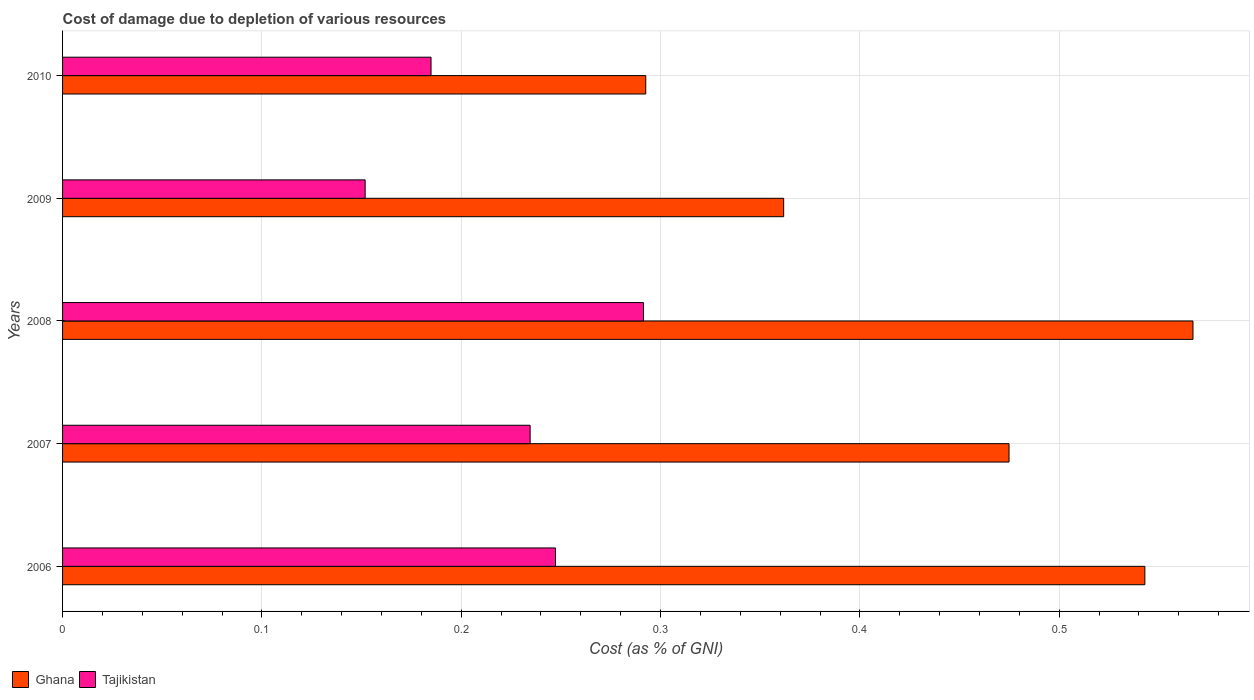Are the number of bars per tick equal to the number of legend labels?
Make the answer very short. Yes. How many bars are there on the 4th tick from the top?
Keep it short and to the point. 2. How many bars are there on the 3rd tick from the bottom?
Your answer should be compact. 2. What is the label of the 1st group of bars from the top?
Offer a terse response. 2010. What is the cost of damage caused due to the depletion of various resources in Ghana in 2010?
Provide a succinct answer. 0.29. Across all years, what is the maximum cost of damage caused due to the depletion of various resources in Ghana?
Your response must be concise. 0.57. Across all years, what is the minimum cost of damage caused due to the depletion of various resources in Tajikistan?
Offer a terse response. 0.15. In which year was the cost of damage caused due to the depletion of various resources in Tajikistan maximum?
Provide a succinct answer. 2008. What is the total cost of damage caused due to the depletion of various resources in Ghana in the graph?
Provide a short and direct response. 2.24. What is the difference between the cost of damage caused due to the depletion of various resources in Ghana in 2009 and that in 2010?
Offer a very short reply. 0.07. What is the difference between the cost of damage caused due to the depletion of various resources in Tajikistan in 2009 and the cost of damage caused due to the depletion of various resources in Ghana in 2007?
Your answer should be compact. -0.32. What is the average cost of damage caused due to the depletion of various resources in Tajikistan per year?
Your answer should be very brief. 0.22. In the year 2009, what is the difference between the cost of damage caused due to the depletion of various resources in Tajikistan and cost of damage caused due to the depletion of various resources in Ghana?
Your answer should be very brief. -0.21. What is the ratio of the cost of damage caused due to the depletion of various resources in Ghana in 2006 to that in 2008?
Give a very brief answer. 0.96. What is the difference between the highest and the second highest cost of damage caused due to the depletion of various resources in Tajikistan?
Make the answer very short. 0.04. What is the difference between the highest and the lowest cost of damage caused due to the depletion of various resources in Ghana?
Your answer should be very brief. 0.27. Is the sum of the cost of damage caused due to the depletion of various resources in Ghana in 2006 and 2010 greater than the maximum cost of damage caused due to the depletion of various resources in Tajikistan across all years?
Keep it short and to the point. Yes. What does the 1st bar from the top in 2009 represents?
Your answer should be very brief. Tajikistan. What does the 1st bar from the bottom in 2010 represents?
Provide a short and direct response. Ghana. How many bars are there?
Offer a very short reply. 10. What is the difference between two consecutive major ticks on the X-axis?
Your response must be concise. 0.1. Are the values on the major ticks of X-axis written in scientific E-notation?
Give a very brief answer. No. Does the graph contain any zero values?
Your answer should be compact. No. How many legend labels are there?
Keep it short and to the point. 2. What is the title of the graph?
Give a very brief answer. Cost of damage due to depletion of various resources. What is the label or title of the X-axis?
Offer a very short reply. Cost (as % of GNI). What is the Cost (as % of GNI) of Ghana in 2006?
Your answer should be compact. 0.54. What is the Cost (as % of GNI) of Tajikistan in 2006?
Make the answer very short. 0.25. What is the Cost (as % of GNI) of Ghana in 2007?
Make the answer very short. 0.47. What is the Cost (as % of GNI) in Tajikistan in 2007?
Your answer should be very brief. 0.23. What is the Cost (as % of GNI) of Ghana in 2008?
Give a very brief answer. 0.57. What is the Cost (as % of GNI) of Tajikistan in 2008?
Your answer should be compact. 0.29. What is the Cost (as % of GNI) of Ghana in 2009?
Provide a succinct answer. 0.36. What is the Cost (as % of GNI) of Tajikistan in 2009?
Your answer should be very brief. 0.15. What is the Cost (as % of GNI) of Ghana in 2010?
Your answer should be compact. 0.29. What is the Cost (as % of GNI) in Tajikistan in 2010?
Ensure brevity in your answer.  0.18. Across all years, what is the maximum Cost (as % of GNI) of Ghana?
Your response must be concise. 0.57. Across all years, what is the maximum Cost (as % of GNI) in Tajikistan?
Your response must be concise. 0.29. Across all years, what is the minimum Cost (as % of GNI) in Ghana?
Your answer should be compact. 0.29. Across all years, what is the minimum Cost (as % of GNI) of Tajikistan?
Keep it short and to the point. 0.15. What is the total Cost (as % of GNI) of Ghana in the graph?
Keep it short and to the point. 2.24. What is the total Cost (as % of GNI) of Tajikistan in the graph?
Make the answer very short. 1.11. What is the difference between the Cost (as % of GNI) in Ghana in 2006 and that in 2007?
Your response must be concise. 0.07. What is the difference between the Cost (as % of GNI) of Tajikistan in 2006 and that in 2007?
Your answer should be very brief. 0.01. What is the difference between the Cost (as % of GNI) of Ghana in 2006 and that in 2008?
Provide a succinct answer. -0.02. What is the difference between the Cost (as % of GNI) of Tajikistan in 2006 and that in 2008?
Provide a short and direct response. -0.04. What is the difference between the Cost (as % of GNI) of Ghana in 2006 and that in 2009?
Ensure brevity in your answer.  0.18. What is the difference between the Cost (as % of GNI) in Tajikistan in 2006 and that in 2009?
Offer a very short reply. 0.1. What is the difference between the Cost (as % of GNI) in Ghana in 2006 and that in 2010?
Ensure brevity in your answer.  0.25. What is the difference between the Cost (as % of GNI) of Tajikistan in 2006 and that in 2010?
Your answer should be very brief. 0.06. What is the difference between the Cost (as % of GNI) in Ghana in 2007 and that in 2008?
Provide a succinct answer. -0.09. What is the difference between the Cost (as % of GNI) in Tajikistan in 2007 and that in 2008?
Provide a short and direct response. -0.06. What is the difference between the Cost (as % of GNI) of Ghana in 2007 and that in 2009?
Your answer should be very brief. 0.11. What is the difference between the Cost (as % of GNI) in Tajikistan in 2007 and that in 2009?
Provide a succinct answer. 0.08. What is the difference between the Cost (as % of GNI) in Ghana in 2007 and that in 2010?
Your response must be concise. 0.18. What is the difference between the Cost (as % of GNI) of Tajikistan in 2007 and that in 2010?
Offer a terse response. 0.05. What is the difference between the Cost (as % of GNI) of Ghana in 2008 and that in 2009?
Ensure brevity in your answer.  0.21. What is the difference between the Cost (as % of GNI) in Tajikistan in 2008 and that in 2009?
Keep it short and to the point. 0.14. What is the difference between the Cost (as % of GNI) of Ghana in 2008 and that in 2010?
Provide a succinct answer. 0.27. What is the difference between the Cost (as % of GNI) in Tajikistan in 2008 and that in 2010?
Your answer should be very brief. 0.11. What is the difference between the Cost (as % of GNI) in Ghana in 2009 and that in 2010?
Offer a terse response. 0.07. What is the difference between the Cost (as % of GNI) of Tajikistan in 2009 and that in 2010?
Your answer should be very brief. -0.03. What is the difference between the Cost (as % of GNI) in Ghana in 2006 and the Cost (as % of GNI) in Tajikistan in 2007?
Offer a terse response. 0.31. What is the difference between the Cost (as % of GNI) in Ghana in 2006 and the Cost (as % of GNI) in Tajikistan in 2008?
Give a very brief answer. 0.25. What is the difference between the Cost (as % of GNI) in Ghana in 2006 and the Cost (as % of GNI) in Tajikistan in 2009?
Your answer should be very brief. 0.39. What is the difference between the Cost (as % of GNI) in Ghana in 2006 and the Cost (as % of GNI) in Tajikistan in 2010?
Offer a terse response. 0.36. What is the difference between the Cost (as % of GNI) in Ghana in 2007 and the Cost (as % of GNI) in Tajikistan in 2008?
Keep it short and to the point. 0.18. What is the difference between the Cost (as % of GNI) of Ghana in 2007 and the Cost (as % of GNI) of Tajikistan in 2009?
Ensure brevity in your answer.  0.32. What is the difference between the Cost (as % of GNI) of Ghana in 2007 and the Cost (as % of GNI) of Tajikistan in 2010?
Your response must be concise. 0.29. What is the difference between the Cost (as % of GNI) in Ghana in 2008 and the Cost (as % of GNI) in Tajikistan in 2009?
Provide a short and direct response. 0.42. What is the difference between the Cost (as % of GNI) in Ghana in 2008 and the Cost (as % of GNI) in Tajikistan in 2010?
Your answer should be very brief. 0.38. What is the difference between the Cost (as % of GNI) of Ghana in 2009 and the Cost (as % of GNI) of Tajikistan in 2010?
Offer a terse response. 0.18. What is the average Cost (as % of GNI) in Ghana per year?
Keep it short and to the point. 0.45. What is the average Cost (as % of GNI) in Tajikistan per year?
Offer a very short reply. 0.22. In the year 2006, what is the difference between the Cost (as % of GNI) of Ghana and Cost (as % of GNI) of Tajikistan?
Ensure brevity in your answer.  0.3. In the year 2007, what is the difference between the Cost (as % of GNI) in Ghana and Cost (as % of GNI) in Tajikistan?
Offer a terse response. 0.24. In the year 2008, what is the difference between the Cost (as % of GNI) in Ghana and Cost (as % of GNI) in Tajikistan?
Your answer should be compact. 0.28. In the year 2009, what is the difference between the Cost (as % of GNI) in Ghana and Cost (as % of GNI) in Tajikistan?
Offer a terse response. 0.21. In the year 2010, what is the difference between the Cost (as % of GNI) in Ghana and Cost (as % of GNI) in Tajikistan?
Keep it short and to the point. 0.11. What is the ratio of the Cost (as % of GNI) in Ghana in 2006 to that in 2007?
Provide a succinct answer. 1.14. What is the ratio of the Cost (as % of GNI) of Tajikistan in 2006 to that in 2007?
Provide a short and direct response. 1.05. What is the ratio of the Cost (as % of GNI) in Ghana in 2006 to that in 2008?
Give a very brief answer. 0.96. What is the ratio of the Cost (as % of GNI) of Tajikistan in 2006 to that in 2008?
Keep it short and to the point. 0.85. What is the ratio of the Cost (as % of GNI) of Ghana in 2006 to that in 2009?
Ensure brevity in your answer.  1.5. What is the ratio of the Cost (as % of GNI) in Tajikistan in 2006 to that in 2009?
Offer a terse response. 1.63. What is the ratio of the Cost (as % of GNI) in Ghana in 2006 to that in 2010?
Provide a short and direct response. 1.86. What is the ratio of the Cost (as % of GNI) in Tajikistan in 2006 to that in 2010?
Your answer should be compact. 1.34. What is the ratio of the Cost (as % of GNI) of Ghana in 2007 to that in 2008?
Keep it short and to the point. 0.84. What is the ratio of the Cost (as % of GNI) of Tajikistan in 2007 to that in 2008?
Keep it short and to the point. 0.8. What is the ratio of the Cost (as % of GNI) of Ghana in 2007 to that in 2009?
Offer a terse response. 1.31. What is the ratio of the Cost (as % of GNI) of Tajikistan in 2007 to that in 2009?
Make the answer very short. 1.55. What is the ratio of the Cost (as % of GNI) of Ghana in 2007 to that in 2010?
Keep it short and to the point. 1.62. What is the ratio of the Cost (as % of GNI) in Tajikistan in 2007 to that in 2010?
Make the answer very short. 1.27. What is the ratio of the Cost (as % of GNI) in Ghana in 2008 to that in 2009?
Give a very brief answer. 1.57. What is the ratio of the Cost (as % of GNI) in Tajikistan in 2008 to that in 2009?
Ensure brevity in your answer.  1.92. What is the ratio of the Cost (as % of GNI) in Ghana in 2008 to that in 2010?
Ensure brevity in your answer.  1.94. What is the ratio of the Cost (as % of GNI) in Tajikistan in 2008 to that in 2010?
Your response must be concise. 1.58. What is the ratio of the Cost (as % of GNI) of Ghana in 2009 to that in 2010?
Make the answer very short. 1.24. What is the ratio of the Cost (as % of GNI) in Tajikistan in 2009 to that in 2010?
Your answer should be very brief. 0.82. What is the difference between the highest and the second highest Cost (as % of GNI) in Ghana?
Offer a terse response. 0.02. What is the difference between the highest and the second highest Cost (as % of GNI) of Tajikistan?
Make the answer very short. 0.04. What is the difference between the highest and the lowest Cost (as % of GNI) in Ghana?
Your answer should be compact. 0.27. What is the difference between the highest and the lowest Cost (as % of GNI) of Tajikistan?
Your answer should be compact. 0.14. 